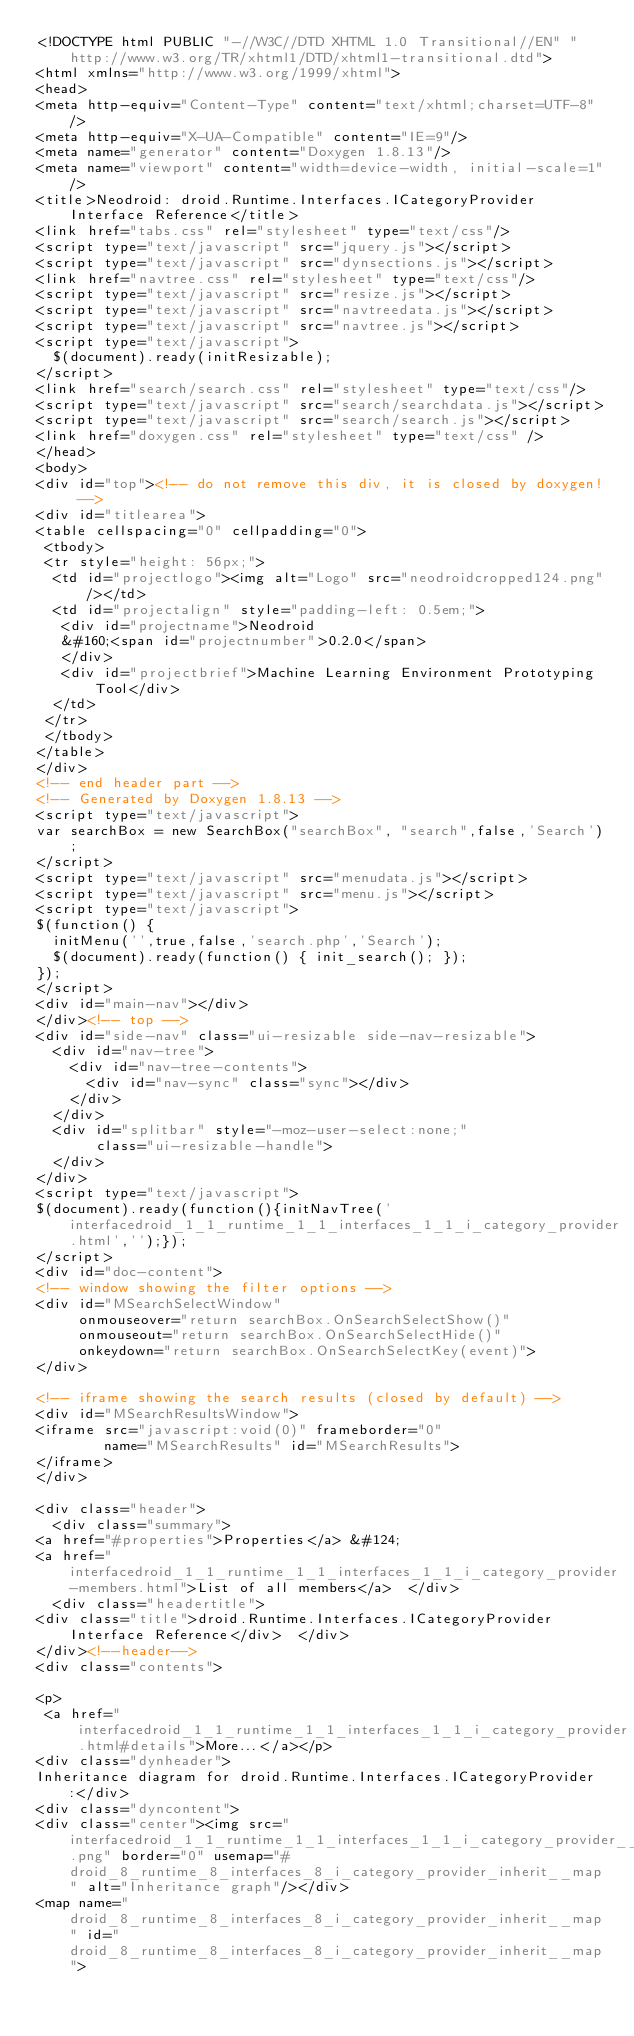Convert code to text. <code><loc_0><loc_0><loc_500><loc_500><_HTML_><!DOCTYPE html PUBLIC "-//W3C//DTD XHTML 1.0 Transitional//EN" "http://www.w3.org/TR/xhtml1/DTD/xhtml1-transitional.dtd">
<html xmlns="http://www.w3.org/1999/xhtml">
<head>
<meta http-equiv="Content-Type" content="text/xhtml;charset=UTF-8"/>
<meta http-equiv="X-UA-Compatible" content="IE=9"/>
<meta name="generator" content="Doxygen 1.8.13"/>
<meta name="viewport" content="width=device-width, initial-scale=1"/>
<title>Neodroid: droid.Runtime.Interfaces.ICategoryProvider Interface Reference</title>
<link href="tabs.css" rel="stylesheet" type="text/css"/>
<script type="text/javascript" src="jquery.js"></script>
<script type="text/javascript" src="dynsections.js"></script>
<link href="navtree.css" rel="stylesheet" type="text/css"/>
<script type="text/javascript" src="resize.js"></script>
<script type="text/javascript" src="navtreedata.js"></script>
<script type="text/javascript" src="navtree.js"></script>
<script type="text/javascript">
  $(document).ready(initResizable);
</script>
<link href="search/search.css" rel="stylesheet" type="text/css"/>
<script type="text/javascript" src="search/searchdata.js"></script>
<script type="text/javascript" src="search/search.js"></script>
<link href="doxygen.css" rel="stylesheet" type="text/css" />
</head>
<body>
<div id="top"><!-- do not remove this div, it is closed by doxygen! -->
<div id="titlearea">
<table cellspacing="0" cellpadding="0">
 <tbody>
 <tr style="height: 56px;">
  <td id="projectlogo"><img alt="Logo" src="neodroidcropped124.png"/></td>
  <td id="projectalign" style="padding-left: 0.5em;">
   <div id="projectname">Neodroid
   &#160;<span id="projectnumber">0.2.0</span>
   </div>
   <div id="projectbrief">Machine Learning Environment Prototyping Tool</div>
  </td>
 </tr>
 </tbody>
</table>
</div>
<!-- end header part -->
<!-- Generated by Doxygen 1.8.13 -->
<script type="text/javascript">
var searchBox = new SearchBox("searchBox", "search",false,'Search');
</script>
<script type="text/javascript" src="menudata.js"></script>
<script type="text/javascript" src="menu.js"></script>
<script type="text/javascript">
$(function() {
  initMenu('',true,false,'search.php','Search');
  $(document).ready(function() { init_search(); });
});
</script>
<div id="main-nav"></div>
</div><!-- top -->
<div id="side-nav" class="ui-resizable side-nav-resizable">
  <div id="nav-tree">
    <div id="nav-tree-contents">
      <div id="nav-sync" class="sync"></div>
    </div>
  </div>
  <div id="splitbar" style="-moz-user-select:none;" 
       class="ui-resizable-handle">
  </div>
</div>
<script type="text/javascript">
$(document).ready(function(){initNavTree('interfacedroid_1_1_runtime_1_1_interfaces_1_1_i_category_provider.html','');});
</script>
<div id="doc-content">
<!-- window showing the filter options -->
<div id="MSearchSelectWindow"
     onmouseover="return searchBox.OnSearchSelectShow()"
     onmouseout="return searchBox.OnSearchSelectHide()"
     onkeydown="return searchBox.OnSearchSelectKey(event)">
</div>

<!-- iframe showing the search results (closed by default) -->
<div id="MSearchResultsWindow">
<iframe src="javascript:void(0)" frameborder="0" 
        name="MSearchResults" id="MSearchResults">
</iframe>
</div>

<div class="header">
  <div class="summary">
<a href="#properties">Properties</a> &#124;
<a href="interfacedroid_1_1_runtime_1_1_interfaces_1_1_i_category_provider-members.html">List of all members</a>  </div>
  <div class="headertitle">
<div class="title">droid.Runtime.Interfaces.ICategoryProvider Interface Reference</div>  </div>
</div><!--header-->
<div class="contents">

<p> 
 <a href="interfacedroid_1_1_runtime_1_1_interfaces_1_1_i_category_provider.html#details">More...</a></p>
<div class="dynheader">
Inheritance diagram for droid.Runtime.Interfaces.ICategoryProvider:</div>
<div class="dyncontent">
<div class="center"><img src="interfacedroid_1_1_runtime_1_1_interfaces_1_1_i_category_provider__inherit__graph.png" border="0" usemap="#droid_8_runtime_8_interfaces_8_i_category_provider_inherit__map" alt="Inheritance graph"/></div>
<map name="droid_8_runtime_8_interfaces_8_i_category_provider_inherit__map" id="droid_8_runtime_8_interfaces_8_i_category_provider_inherit__map"></code> 